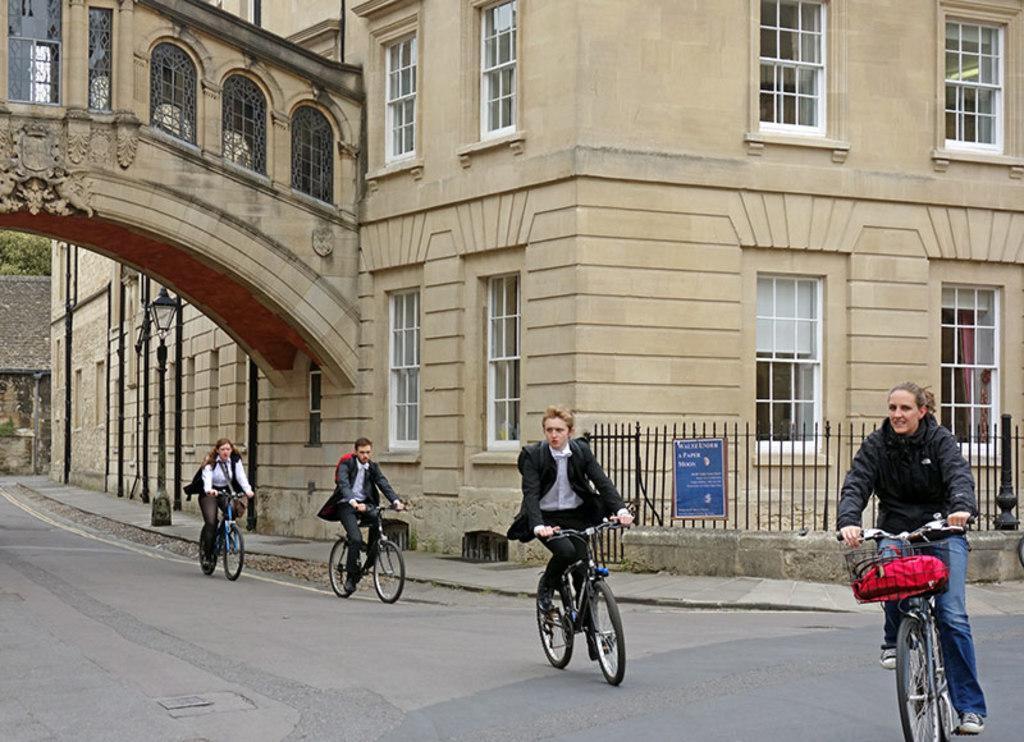In one or two sentences, can you explain what this image depicts? In this image, there are four persons riding a bicycle. In the background of the image, there is a building and there are windows visible. In the background middle left, there are trees visible. And this picture is taken during a day time on the road. 